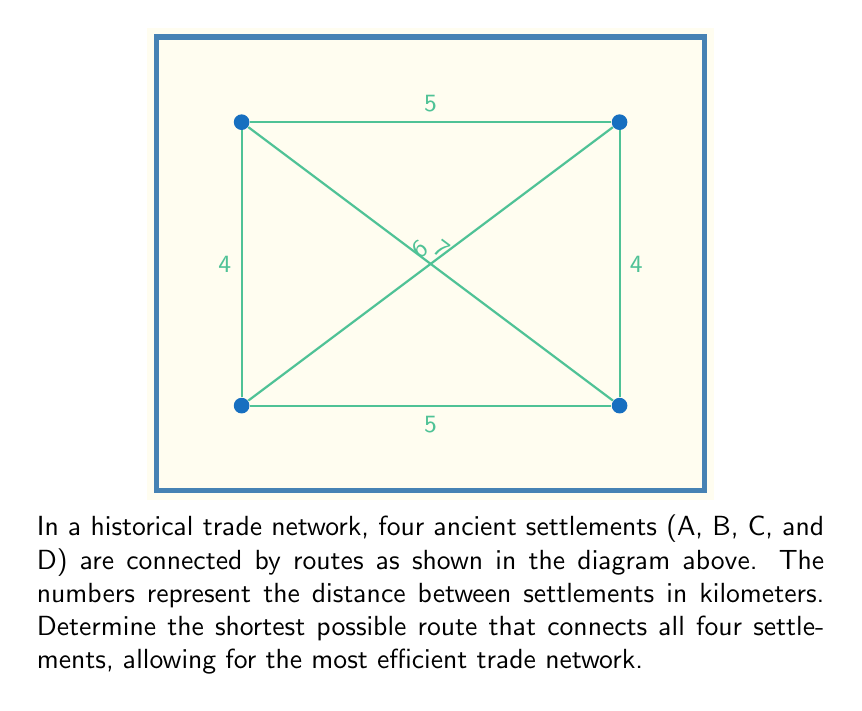Show me your answer to this math problem. To find the optimal route for the trade network, we need to determine the shortest path that connects all four settlements. This is known as the Minimum Spanning Tree (MST) problem. We can solve this using Kruskal's algorithm:

1. List all edges and their weights (distances):
   AB: 5, BC: 4, CD: 5, DA: 4, AC: 6, BD: 7

2. Sort the edges by weight in ascending order:
   BC: 4, DA: 4, AB: 5, CD: 5, AC: 6, BD: 7

3. Add edges to the spanning tree, starting with the shortest, as long as they don't create a cycle:
   - Add BC (4 km)
   - Add DA (4 km)
   - Add AB (5 km)

4. After adding these three edges, we have connected all four settlements without creating any cycles. The total distance is:

   $$ \text{Total distance} = BC + DA + AB = 4 + 4 + 5 = 13 \text{ km} $$

This configuration forms a path A-B-C-D, which is the optimal route for the trade network.
Answer: 13 km (A-B-C-D) 